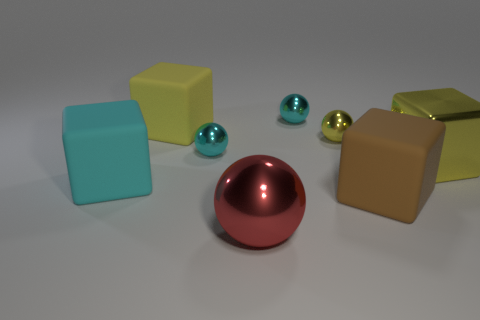Add 2 red metallic objects. How many objects exist? 10 Subtract all large yellow rubber cubes. How many cubes are left? 3 Subtract all red blocks. How many cyan spheres are left? 2 Subtract all cyan blocks. How many blocks are left? 3 Add 7 large cyan matte objects. How many large cyan matte objects are left? 8 Add 4 red balls. How many red balls exist? 5 Subtract 1 red balls. How many objects are left? 7 Subtract 1 balls. How many balls are left? 3 Subtract all blue balls. Subtract all brown cubes. How many balls are left? 4 Subtract all big metallic spheres. Subtract all cyan metal spheres. How many objects are left? 5 